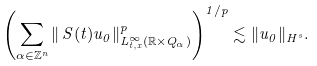<formula> <loc_0><loc_0><loc_500><loc_500>\left ( \sum _ { \alpha \in \mathbb { Z } ^ { n } } \| \, S ( t ) u _ { 0 } \| ^ { p } _ { L ^ { \infty } _ { t , x } ( \mathbb { R } \times Q _ { \alpha } ) } \right ) ^ { 1 / p } \lesssim \| u _ { 0 } \| _ { H ^ { s } } .</formula> 